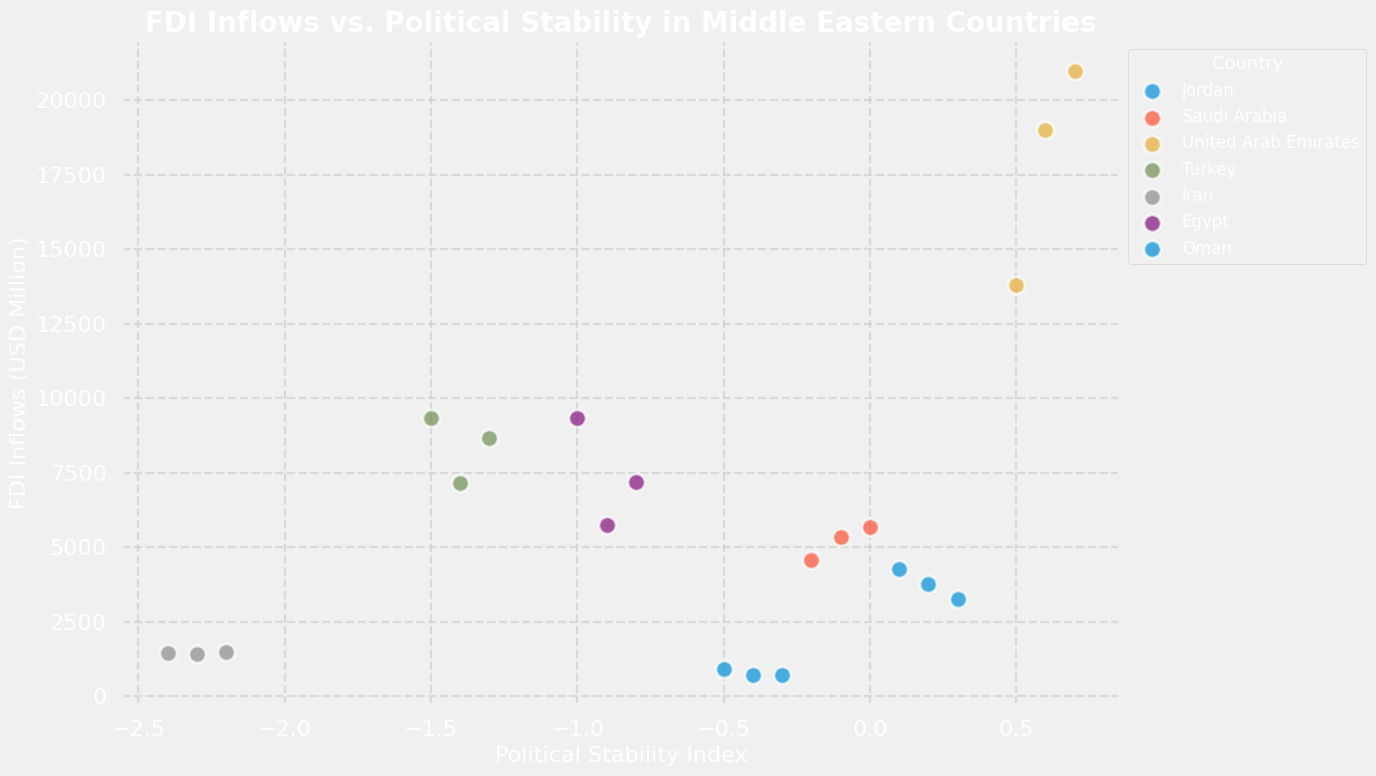What is the trend in Political Stability Index for Jordan from 2019 to 2021? To determine the trend, look at the Political Stability Index values for Jordan over the years 2019, 2020, and 2021. The values increase from -0.5 in 2019, to -0.4 in 2020, and -0.3 in 2021, showing an upward trend.
Answer: Upward trend Which country had the highest FDI inflows in 2021? Look at the FDI inflows for all countries in the year 2021. The country with the highest value is the United Arab Emirates with 21000 USD Million.
Answer: United Arab Emirates What is the average FDI inflows for Turkey across the years 2019, 2020, and 2021? Sum the FDI inflows for Turkey over the three years (8683 + 7172 + 9355) and then divide by the number of years (3). This yields (8683 + 7172 + 9355) / 3 = 25210 / 3 ≈ 8403 USD Million.
Answer: ≈ 8403 USD Million Compare the FDI inflows in 2020 between Egypt and Iran. Which country had higher FDI inflows? Look at the FDI inflows for Egypt and Iran in 2020. Egypt had 5752 USD Million and Iran had 1424 USD Million. Egypt had higher FDI inflows.
Answer: Egypt For which country did the Political Stability Index improve the most from 2019 to 2021? Calculate the difference between the 2021 and 2019 Political Stability Index for each country. The changes are:
- Jordan: -0.3 - (-0.5) = 0.2
- Saudi Arabia: 0 - (-0.2) = 0.2
- United Arab Emirates: 0.7 - 0.5 = 0.2
- Turkey: -1.5 - (-1.3) = -0.2
- Iran: -2.2 - (-2.4) = 0.2
- Egypt: -0.8 - (-1) = 0.2
- Oman: 0.3 - 0.1 = 0.2
Since all these countries have the same amount of improvement, but considering multiple steps, any of them can be chosen.
Answer: Multiple countries improved by 0.2 Which country shows a decrease in both FDI inflows and Political Stability Index from 2019 to 2021? Analyze each country's trend for both FDI inflows and Political Stability Index. Turkey is the only country where both FDI inflows and Political Stability Index decreased:
- FDI inflows: 8683 (2019), 7172 (2020), 9355 (2021) -> mixed
- Political Stability Index: -1.3 (2019), -1.4 (2020), -1.5 (2021) -> decreased consistently
Answer: Turkey What is the correlation between Political Stability Index and FDI inflows for Saudi Arabia? By visually examining the relationship between the Political Stability Index and FDI inflows for Saudi Arabia over the years, it can be observed that as the Political Stability Index increases from -0.2 to 0, the FDI inflows also increase from 4562 to 5672 USD Million, indicating a positive correlation.
Answer: Positive correlation 